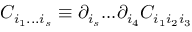<formula> <loc_0><loc_0><loc_500><loc_500>C _ { i _ { 1 } \dots i _ { s } } \equiv \partial _ { i _ { s } } \dots \partial _ { i _ { 4 } } C _ { i _ { 1 } i _ { 2 } i _ { 3 } }</formula> 